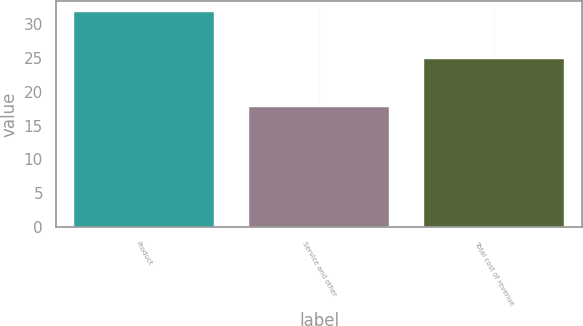<chart> <loc_0><loc_0><loc_500><loc_500><bar_chart><fcel>Product<fcel>Service and other<fcel>Total cost of revenue<nl><fcel>31.8<fcel>17.7<fcel>24.8<nl></chart> 